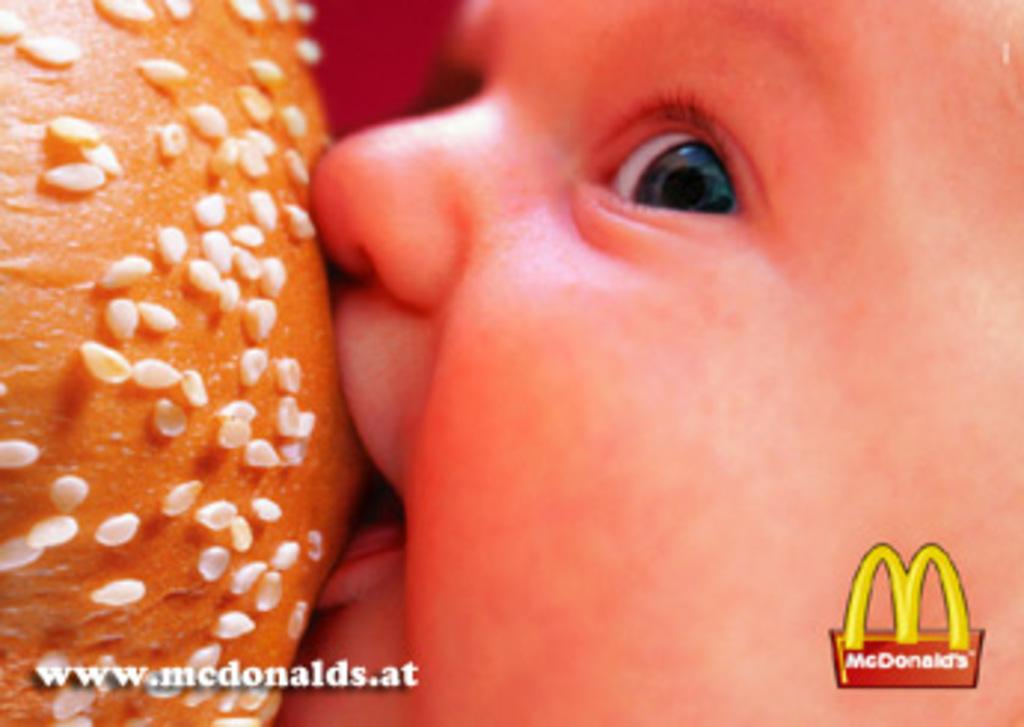What is the main subject of the image? The main subject of the image is a kid. What is the kid doing in the image? The kid is eating a bun in the image. Can you describe any imperfections or marks on the image? Yes, there are watermarks on the image. What type of copper material can be seen in the image? There is no copper material present in the image. How many pages are visible in the image? The image does not depict any pages, as it features a kid eating a bun. 